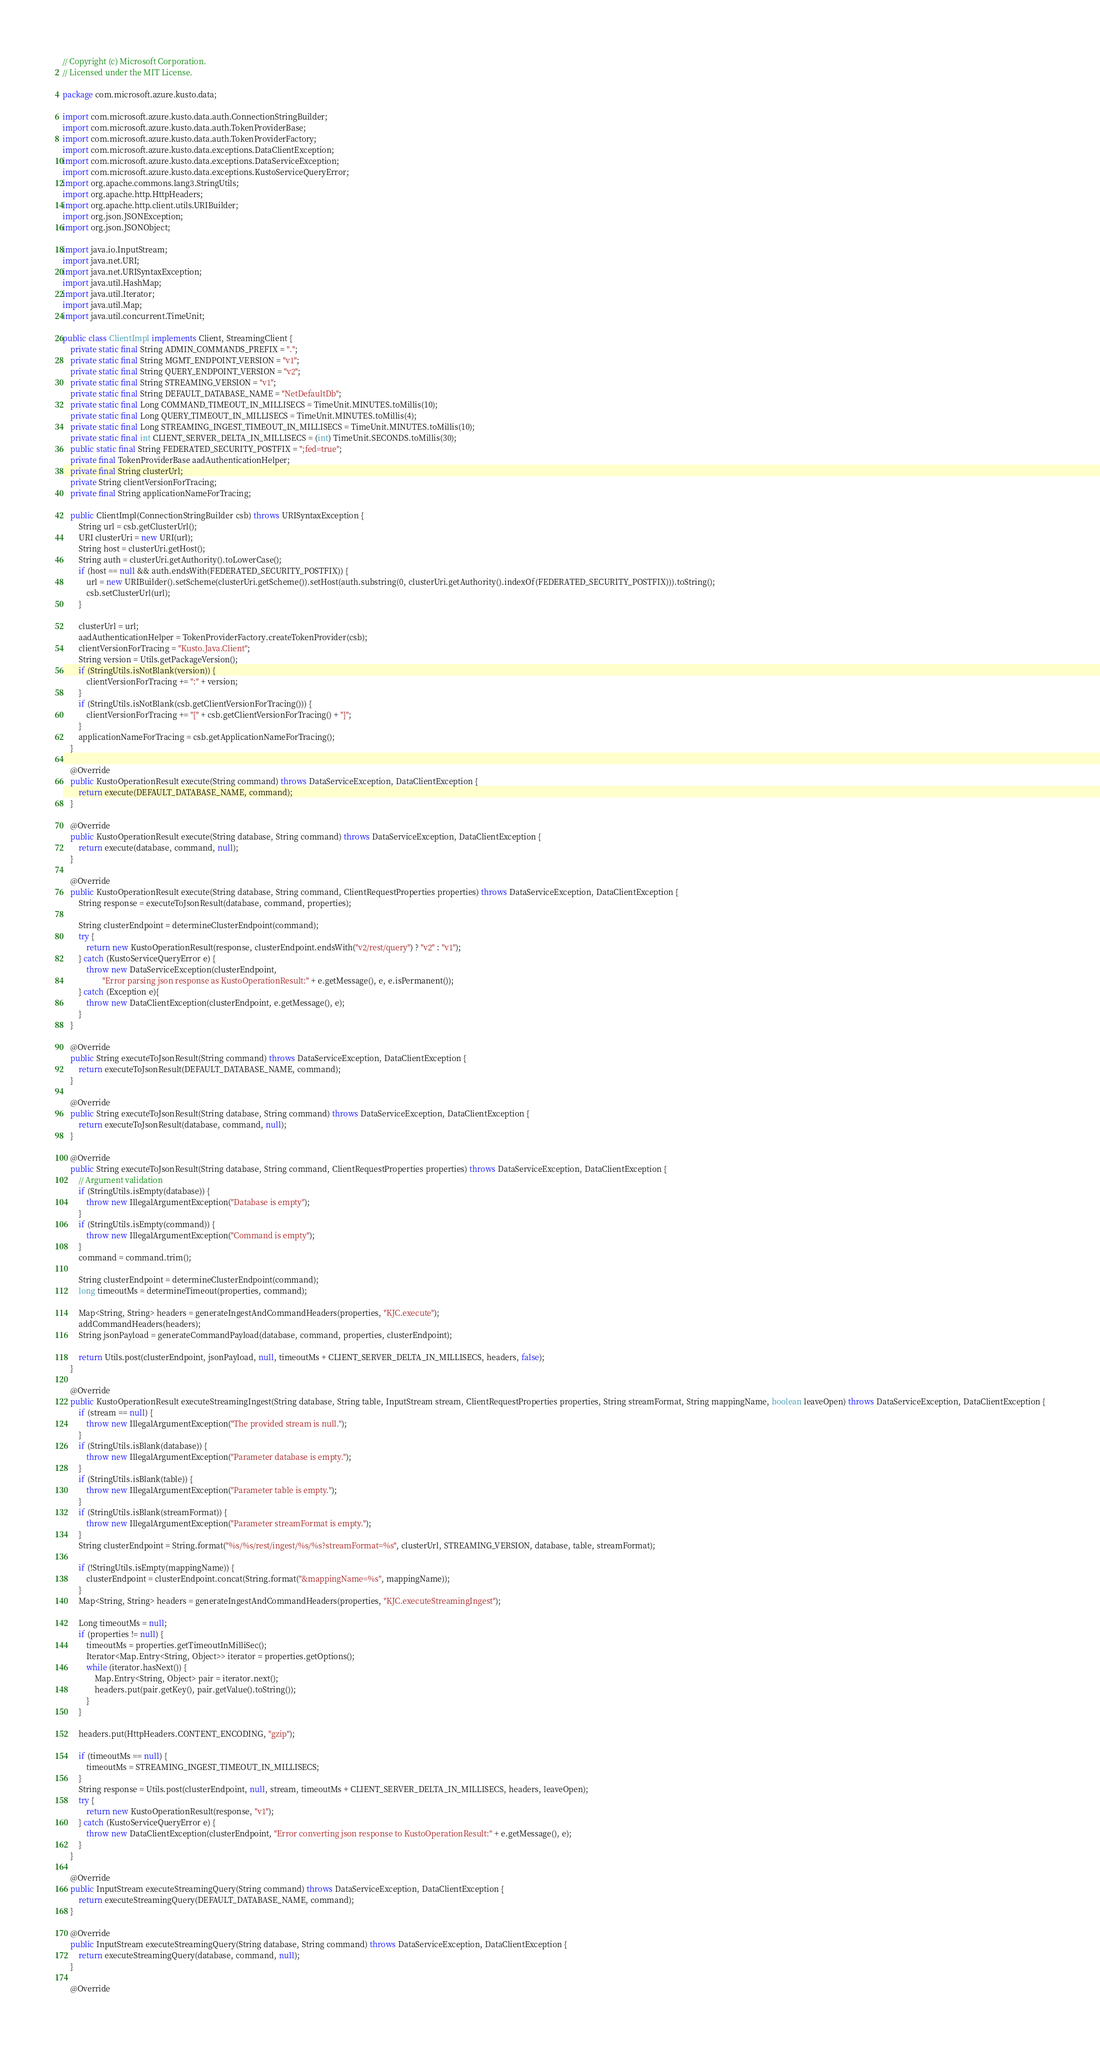Convert code to text. <code><loc_0><loc_0><loc_500><loc_500><_Java_>// Copyright (c) Microsoft Corporation.
// Licensed under the MIT License.

package com.microsoft.azure.kusto.data;

import com.microsoft.azure.kusto.data.auth.ConnectionStringBuilder;
import com.microsoft.azure.kusto.data.auth.TokenProviderBase;
import com.microsoft.azure.kusto.data.auth.TokenProviderFactory;
import com.microsoft.azure.kusto.data.exceptions.DataClientException;
import com.microsoft.azure.kusto.data.exceptions.DataServiceException;
import com.microsoft.azure.kusto.data.exceptions.KustoServiceQueryError;
import org.apache.commons.lang3.StringUtils;
import org.apache.http.HttpHeaders;
import org.apache.http.client.utils.URIBuilder;
import org.json.JSONException;
import org.json.JSONObject;

import java.io.InputStream;
import java.net.URI;
import java.net.URISyntaxException;
import java.util.HashMap;
import java.util.Iterator;
import java.util.Map;
import java.util.concurrent.TimeUnit;

public class ClientImpl implements Client, StreamingClient {
    private static final String ADMIN_COMMANDS_PREFIX = ".";
    private static final String MGMT_ENDPOINT_VERSION = "v1";
    private static final String QUERY_ENDPOINT_VERSION = "v2";
    private static final String STREAMING_VERSION = "v1";
    private static final String DEFAULT_DATABASE_NAME = "NetDefaultDb";
    private static final Long COMMAND_TIMEOUT_IN_MILLISECS = TimeUnit.MINUTES.toMillis(10);
    private static final Long QUERY_TIMEOUT_IN_MILLISECS = TimeUnit.MINUTES.toMillis(4);
    private static final Long STREAMING_INGEST_TIMEOUT_IN_MILLISECS = TimeUnit.MINUTES.toMillis(10);
    private static final int CLIENT_SERVER_DELTA_IN_MILLISECS = (int) TimeUnit.SECONDS.toMillis(30);
    public static final String FEDERATED_SECURITY_POSTFIX = ";fed=true";
    private final TokenProviderBase aadAuthenticationHelper;
    private final String clusterUrl;
    private String clientVersionForTracing;
    private final String applicationNameForTracing;

    public ClientImpl(ConnectionStringBuilder csb) throws URISyntaxException {
        String url = csb.getClusterUrl();
        URI clusterUri = new URI(url);
        String host = clusterUri.getHost();
        String auth = clusterUri.getAuthority().toLowerCase();
        if (host == null && auth.endsWith(FEDERATED_SECURITY_POSTFIX)) {
            url = new URIBuilder().setScheme(clusterUri.getScheme()).setHost(auth.substring(0, clusterUri.getAuthority().indexOf(FEDERATED_SECURITY_POSTFIX))).toString();
            csb.setClusterUrl(url);
        }

        clusterUrl = url;
        aadAuthenticationHelper = TokenProviderFactory.createTokenProvider(csb);
        clientVersionForTracing = "Kusto.Java.Client";
        String version = Utils.getPackageVersion();
        if (StringUtils.isNotBlank(version)) {
            clientVersionForTracing += ":" + version;
        }
        if (StringUtils.isNotBlank(csb.getClientVersionForTracing())) {
            clientVersionForTracing += "[" + csb.getClientVersionForTracing() + "]";
        }
        applicationNameForTracing = csb.getApplicationNameForTracing();
    }

    @Override
    public KustoOperationResult execute(String command) throws DataServiceException, DataClientException {
        return execute(DEFAULT_DATABASE_NAME, command);
    }

    @Override
    public KustoOperationResult execute(String database, String command) throws DataServiceException, DataClientException {
        return execute(database, command, null);
    }

    @Override
    public KustoOperationResult execute(String database, String command, ClientRequestProperties properties) throws DataServiceException, DataClientException {
        String response = executeToJsonResult(database, command, properties);

        String clusterEndpoint = determineClusterEndpoint(command);
        try {
            return new KustoOperationResult(response, clusterEndpoint.endsWith("v2/rest/query") ? "v2" : "v1");
        } catch (KustoServiceQueryError e) {
            throw new DataServiceException(clusterEndpoint,
                    "Error parsing json response as KustoOperationResult:" + e.getMessage(), e, e.isPermanent());
        } catch (Exception e){
            throw new DataClientException(clusterEndpoint, e.getMessage(), e);
        }
    }

    @Override
    public String executeToJsonResult(String command) throws DataServiceException, DataClientException {
        return executeToJsonResult(DEFAULT_DATABASE_NAME, command);
    }

    @Override
    public String executeToJsonResult(String database, String command) throws DataServiceException, DataClientException {
        return executeToJsonResult(database, command, null);
    }

    @Override
    public String executeToJsonResult(String database, String command, ClientRequestProperties properties) throws DataServiceException, DataClientException {
        // Argument validation
        if (StringUtils.isEmpty(database)) {
            throw new IllegalArgumentException("Database is empty");
        }
        if (StringUtils.isEmpty(command)) {
            throw new IllegalArgumentException("Command is empty");
        }
        command = command.trim();

        String clusterEndpoint = determineClusterEndpoint(command);
        long timeoutMs = determineTimeout(properties, command);

        Map<String, String> headers = generateIngestAndCommandHeaders(properties, "KJC.execute");
        addCommandHeaders(headers);
        String jsonPayload = generateCommandPayload(database, command, properties, clusterEndpoint);

        return Utils.post(clusterEndpoint, jsonPayload, null, timeoutMs + CLIENT_SERVER_DELTA_IN_MILLISECS, headers, false);
    }

    @Override
    public KustoOperationResult executeStreamingIngest(String database, String table, InputStream stream, ClientRequestProperties properties, String streamFormat, String mappingName, boolean leaveOpen) throws DataServiceException, DataClientException {
        if (stream == null) {
            throw new IllegalArgumentException("The provided stream is null.");
        }
        if (StringUtils.isBlank(database)) {
            throw new IllegalArgumentException("Parameter database is empty.");
        }
        if (StringUtils.isBlank(table)) {
            throw new IllegalArgumentException("Parameter table is empty.");
        }
        if (StringUtils.isBlank(streamFormat)) {
            throw new IllegalArgumentException("Parameter streamFormat is empty.");
        }
        String clusterEndpoint = String.format("%s/%s/rest/ingest/%s/%s?streamFormat=%s", clusterUrl, STREAMING_VERSION, database, table, streamFormat);

        if (!StringUtils.isEmpty(mappingName)) {
            clusterEndpoint = clusterEndpoint.concat(String.format("&mappingName=%s", mappingName));
        }
        Map<String, String> headers = generateIngestAndCommandHeaders(properties, "KJC.executeStreamingIngest");

        Long timeoutMs = null;
        if (properties != null) {
            timeoutMs = properties.getTimeoutInMilliSec();
            Iterator<Map.Entry<String, Object>> iterator = properties.getOptions();
            while (iterator.hasNext()) {
                Map.Entry<String, Object> pair = iterator.next();
                headers.put(pair.getKey(), pair.getValue().toString());
            }
        }

        headers.put(HttpHeaders.CONTENT_ENCODING, "gzip");

        if (timeoutMs == null) {
            timeoutMs = STREAMING_INGEST_TIMEOUT_IN_MILLISECS;
        }
        String response = Utils.post(clusterEndpoint, null, stream, timeoutMs + CLIENT_SERVER_DELTA_IN_MILLISECS, headers, leaveOpen);
        try {
            return new KustoOperationResult(response, "v1");
        } catch (KustoServiceQueryError e) {
            throw new DataClientException(clusterEndpoint, "Error converting json response to KustoOperationResult:" + e.getMessage(), e);
        }
    }

    @Override
    public InputStream executeStreamingQuery(String command) throws DataServiceException, DataClientException {
        return executeStreamingQuery(DEFAULT_DATABASE_NAME, command);
    }

    @Override
    public InputStream executeStreamingQuery(String database, String command) throws DataServiceException, DataClientException {
        return executeStreamingQuery(database, command, null);
    }

    @Override</code> 